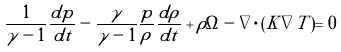Convert formula to latex. <formula><loc_0><loc_0><loc_500><loc_500>\frac { 1 } { \gamma - 1 } \frac { d p } { d t } - \frac { \gamma } { \gamma - 1 } \frac { p } { \rho } \frac { d { \rho } } { d t } + \rho \Omega - \nabla \cdot ( K \nabla T ) = 0</formula> 